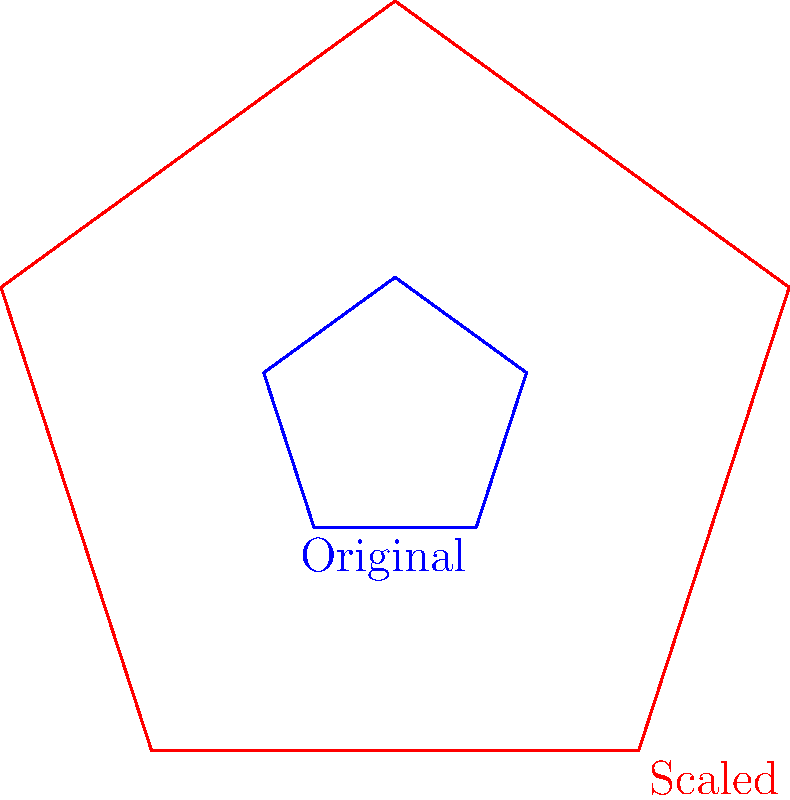As a sports journalist covering NCAA football, you're tasked with analyzing the expansion plans for a college stadium. The current seating chart is represented by the blue pentagon, and the proposed expansion is shown by the red pentagon. If the original stadium capacity is 40,000, what would be the new capacity after the expansion, assuming the seating density remains constant? To solve this problem, we need to understand the concept of scaling and its effect on area. Let's break it down step-by-step:

1) Observe that the red pentagon is an enlarged version of the blue pentagon, maintaining the same shape (proportions).

2) The scaling factor can be determined by comparing the side lengths or distances from the center to any vertex of the two pentagons.

3) From the diagram, we can see that the red pentagon is 3 times larger than the blue pentagon (1.5 / 0.5 = 3).

4) When a two-dimensional figure is scaled by a factor of $k$, its area is scaled by a factor of $k^2$.

5) In this case, the scaling factor $k = 3$, so the area scaling factor is $3^2 = 9$.

6) Since the seating density remains constant, the new capacity will be 9 times the original capacity.

7) Calculate: New capacity = Original capacity $\times$ Area scaling factor
                           $= 40,000 \times 9$
                           $= 360,000$

Therefore, the new stadium capacity after the expansion would be 360,000.
Answer: 360,000 